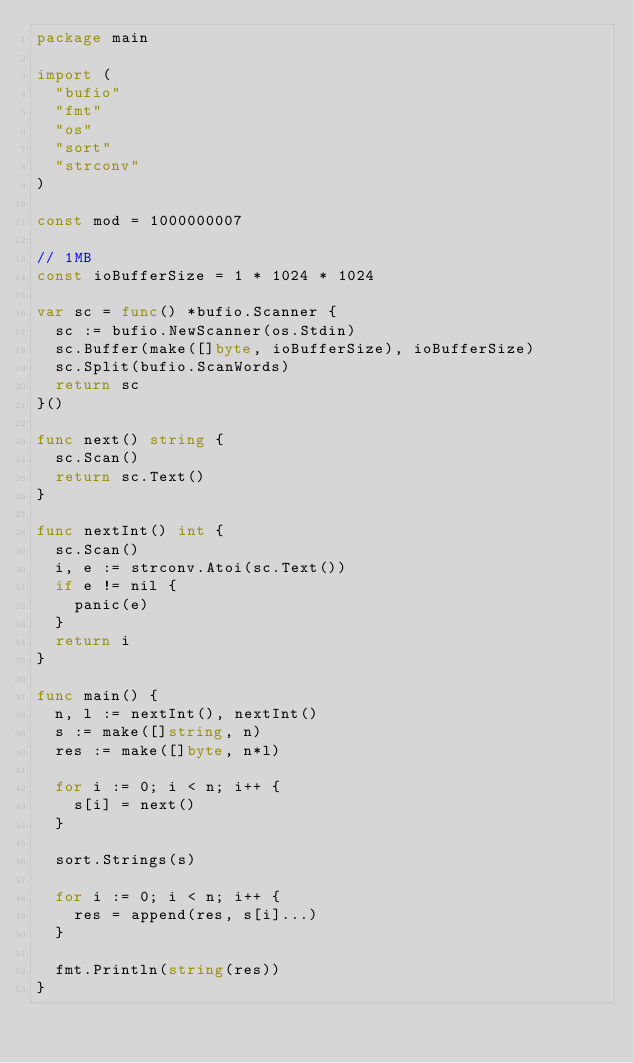<code> <loc_0><loc_0><loc_500><loc_500><_Go_>package main

import (
	"bufio"
	"fmt"
	"os"
	"sort"
	"strconv"
)

const mod = 1000000007

// 1MB
const ioBufferSize = 1 * 1024 * 1024

var sc = func() *bufio.Scanner {
	sc := bufio.NewScanner(os.Stdin)
	sc.Buffer(make([]byte, ioBufferSize), ioBufferSize)
	sc.Split(bufio.ScanWords)
	return sc
}()

func next() string {
	sc.Scan()
	return sc.Text()
}

func nextInt() int {
	sc.Scan()
	i, e := strconv.Atoi(sc.Text())
	if e != nil {
		panic(e)
	}
	return i
}

func main() {
	n, l := nextInt(), nextInt()
	s := make([]string, n)
	res := make([]byte, n*l)

	for i := 0; i < n; i++ {
		s[i] = next()
	}

	sort.Strings(s)

	for i := 0; i < n; i++ {
		res = append(res, s[i]...)
	}

	fmt.Println(string(res))
}
</code> 